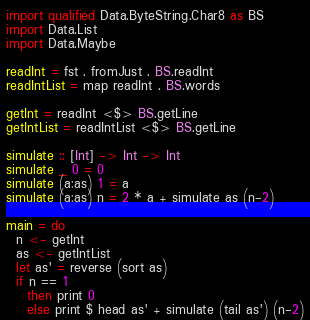<code> <loc_0><loc_0><loc_500><loc_500><_Haskell_>import qualified Data.ByteString.Char8 as BS
import Data.List
import Data.Maybe

readInt = fst . fromJust . BS.readInt
readIntList = map readInt . BS.words

getInt = readInt <$> BS.getLine
getIntList = readIntList <$> BS.getLine

simulate :: [Int] -> Int -> Int
simulate _ 0 = 0
simulate (a:as) 1 = a
simulate (a:as) n = 2 * a + simulate as (n-2)

main = do
  n <- getInt
  as <- getIntList
  let as' = reverse (sort as)
  if n == 1
    then print 0
    else print $ head as' + simulate (tail as') (n-2)
</code> 